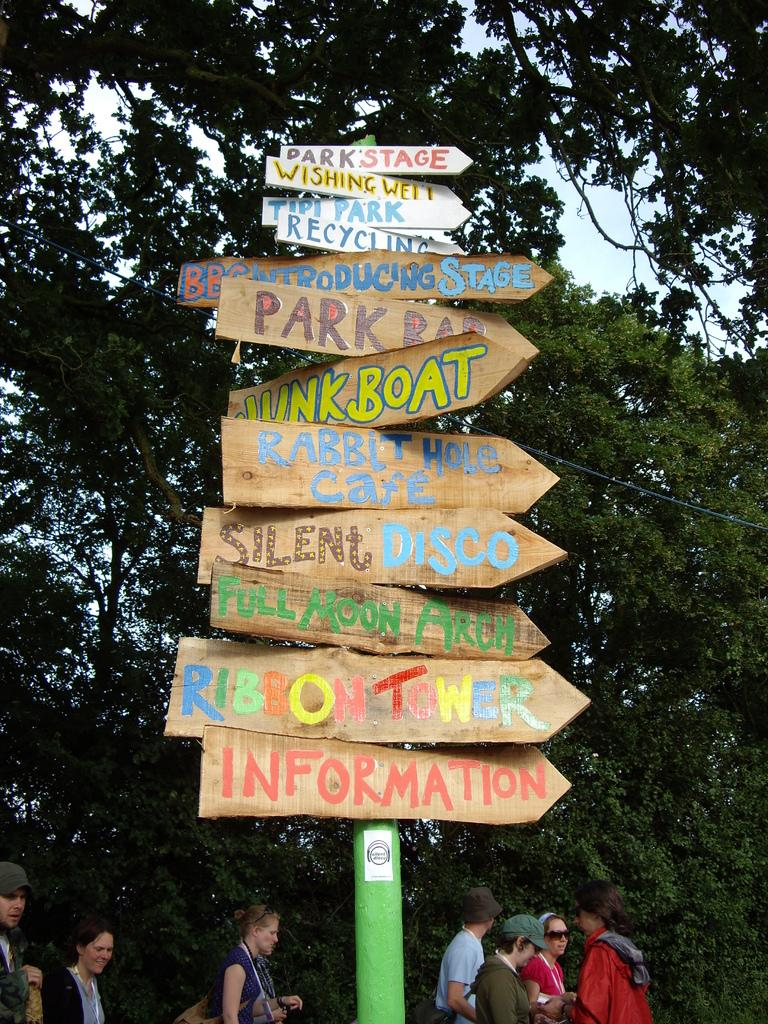What objects are present in the image that are made of wood or a similar material? There are boards in the image. What is written on the boards in the image? There is writing on the boards. Who or what can be seen in the image besides the boards? There are people and trees in the image. What can be seen in the distance in the image? The sky is visible in the background of the image. What type of stocking is hanging from the tree in the image? There is no stocking hanging from the tree in the image; only boards, writing, people, trees, and the sky are present. 